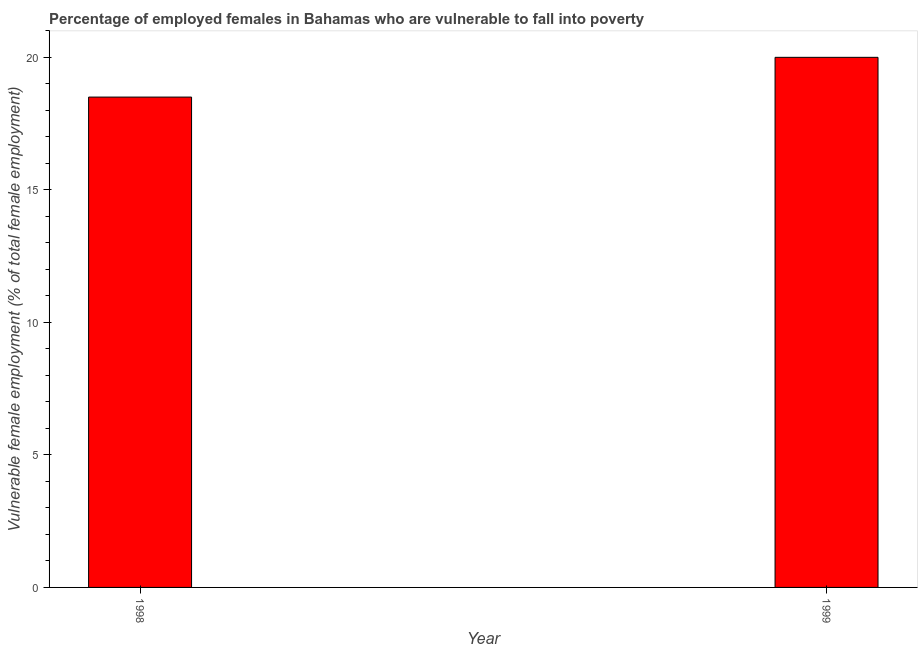Does the graph contain grids?
Your answer should be compact. No. What is the title of the graph?
Provide a succinct answer. Percentage of employed females in Bahamas who are vulnerable to fall into poverty. What is the label or title of the Y-axis?
Provide a succinct answer. Vulnerable female employment (% of total female employment). Across all years, what is the minimum percentage of employed females who are vulnerable to fall into poverty?
Provide a short and direct response. 18.5. What is the sum of the percentage of employed females who are vulnerable to fall into poverty?
Provide a succinct answer. 38.5. What is the average percentage of employed females who are vulnerable to fall into poverty per year?
Your answer should be compact. 19.25. What is the median percentage of employed females who are vulnerable to fall into poverty?
Ensure brevity in your answer.  19.25. What is the ratio of the percentage of employed females who are vulnerable to fall into poverty in 1998 to that in 1999?
Provide a short and direct response. 0.93. In how many years, is the percentage of employed females who are vulnerable to fall into poverty greater than the average percentage of employed females who are vulnerable to fall into poverty taken over all years?
Offer a very short reply. 1. How many bars are there?
Provide a short and direct response. 2. What is the Vulnerable female employment (% of total female employment) of 1998?
Ensure brevity in your answer.  18.5. What is the ratio of the Vulnerable female employment (% of total female employment) in 1998 to that in 1999?
Offer a terse response. 0.93. 